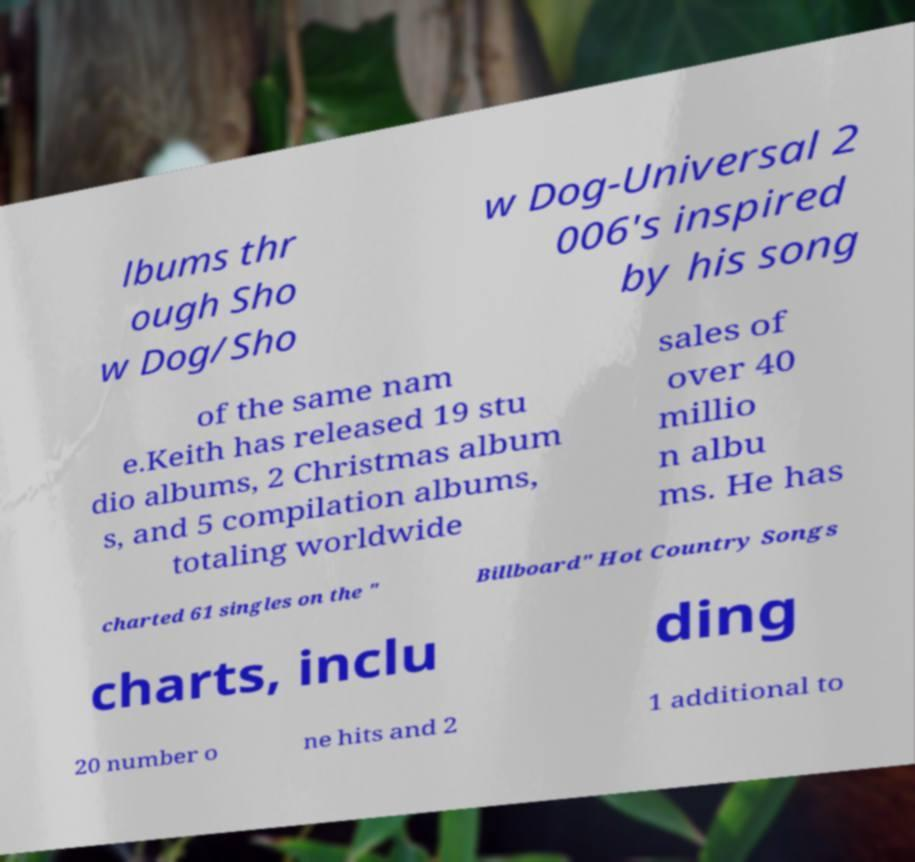Please identify and transcribe the text found in this image. lbums thr ough Sho w Dog/Sho w Dog-Universal 2 006's inspired by his song of the same nam e.Keith has released 19 stu dio albums, 2 Christmas album s, and 5 compilation albums, totaling worldwide sales of over 40 millio n albu ms. He has charted 61 singles on the " Billboard" Hot Country Songs charts, inclu ding 20 number o ne hits and 2 1 additional to 